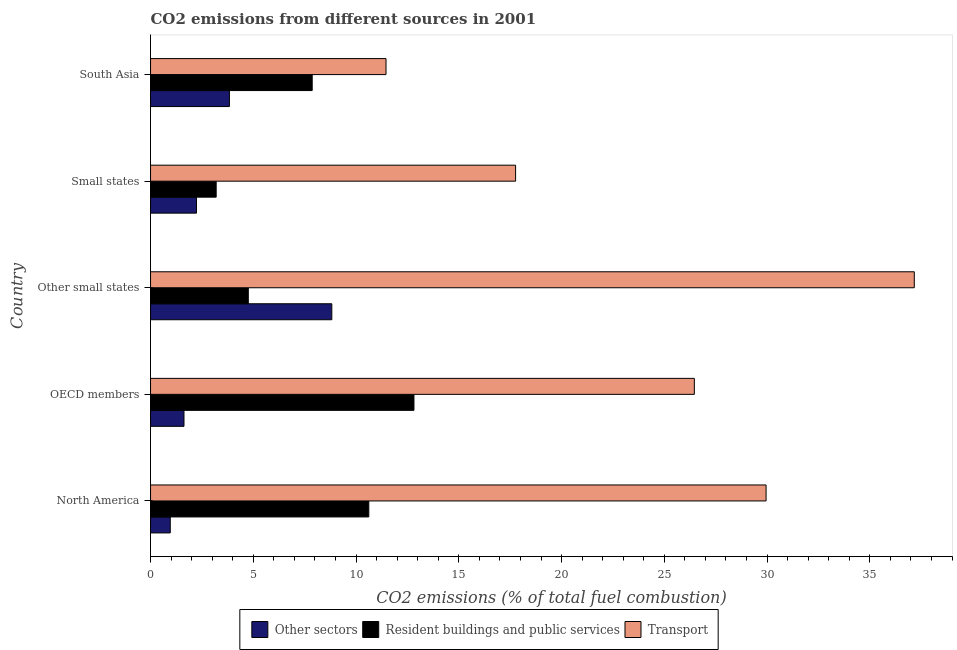Are the number of bars on each tick of the Y-axis equal?
Make the answer very short. Yes. What is the percentage of co2 emissions from resident buildings and public services in South Asia?
Your answer should be compact. 7.87. Across all countries, what is the maximum percentage of co2 emissions from other sectors?
Provide a short and direct response. 8.82. Across all countries, what is the minimum percentage of co2 emissions from other sectors?
Your answer should be compact. 0.96. In which country was the percentage of co2 emissions from resident buildings and public services maximum?
Give a very brief answer. OECD members. In which country was the percentage of co2 emissions from other sectors minimum?
Keep it short and to the point. North America. What is the total percentage of co2 emissions from transport in the graph?
Ensure brevity in your answer.  122.8. What is the difference between the percentage of co2 emissions from other sectors in Other small states and that in South Asia?
Keep it short and to the point. 4.98. What is the difference between the percentage of co2 emissions from other sectors in OECD members and the percentage of co2 emissions from resident buildings and public services in Other small states?
Offer a terse response. -3.13. What is the average percentage of co2 emissions from other sectors per country?
Your response must be concise. 3.5. What is the difference between the percentage of co2 emissions from resident buildings and public services and percentage of co2 emissions from transport in South Asia?
Provide a succinct answer. -3.59. What is the ratio of the percentage of co2 emissions from resident buildings and public services in OECD members to that in South Asia?
Offer a very short reply. 1.63. Is the percentage of co2 emissions from transport in OECD members less than that in South Asia?
Give a very brief answer. No. Is the difference between the percentage of co2 emissions from other sectors in Other small states and Small states greater than the difference between the percentage of co2 emissions from resident buildings and public services in Other small states and Small states?
Offer a terse response. Yes. What is the difference between the highest and the second highest percentage of co2 emissions from resident buildings and public services?
Make the answer very short. 2.2. What is the difference between the highest and the lowest percentage of co2 emissions from transport?
Offer a terse response. 25.71. What does the 2nd bar from the top in Other small states represents?
Provide a short and direct response. Resident buildings and public services. What does the 2nd bar from the bottom in Other small states represents?
Your response must be concise. Resident buildings and public services. How many bars are there?
Provide a short and direct response. 15. What is the difference between two consecutive major ticks on the X-axis?
Provide a succinct answer. 5. Are the values on the major ticks of X-axis written in scientific E-notation?
Make the answer very short. No. Where does the legend appear in the graph?
Your answer should be very brief. Bottom center. How many legend labels are there?
Give a very brief answer. 3. What is the title of the graph?
Provide a short and direct response. CO2 emissions from different sources in 2001. Does "Nuclear sources" appear as one of the legend labels in the graph?
Offer a very short reply. No. What is the label or title of the X-axis?
Your answer should be compact. CO2 emissions (% of total fuel combustion). What is the CO2 emissions (% of total fuel combustion) in Other sectors in North America?
Provide a succinct answer. 0.96. What is the CO2 emissions (% of total fuel combustion) of Resident buildings and public services in North America?
Your answer should be compact. 10.62. What is the CO2 emissions (% of total fuel combustion) of Transport in North America?
Ensure brevity in your answer.  29.95. What is the CO2 emissions (% of total fuel combustion) of Other sectors in OECD members?
Give a very brief answer. 1.63. What is the CO2 emissions (% of total fuel combustion) in Resident buildings and public services in OECD members?
Provide a short and direct response. 12.82. What is the CO2 emissions (% of total fuel combustion) of Transport in OECD members?
Your answer should be compact. 26.46. What is the CO2 emissions (% of total fuel combustion) of Other sectors in Other small states?
Your answer should be very brief. 8.82. What is the CO2 emissions (% of total fuel combustion) in Resident buildings and public services in Other small states?
Your answer should be very brief. 4.76. What is the CO2 emissions (% of total fuel combustion) in Transport in Other small states?
Offer a very short reply. 37.17. What is the CO2 emissions (% of total fuel combustion) in Other sectors in Small states?
Offer a very short reply. 2.24. What is the CO2 emissions (% of total fuel combustion) in Resident buildings and public services in Small states?
Your answer should be compact. 3.19. What is the CO2 emissions (% of total fuel combustion) of Transport in Small states?
Provide a succinct answer. 17.76. What is the CO2 emissions (% of total fuel combustion) in Other sectors in South Asia?
Ensure brevity in your answer.  3.84. What is the CO2 emissions (% of total fuel combustion) in Resident buildings and public services in South Asia?
Ensure brevity in your answer.  7.87. What is the CO2 emissions (% of total fuel combustion) in Transport in South Asia?
Your response must be concise. 11.46. Across all countries, what is the maximum CO2 emissions (% of total fuel combustion) in Other sectors?
Provide a short and direct response. 8.82. Across all countries, what is the maximum CO2 emissions (% of total fuel combustion) in Resident buildings and public services?
Provide a short and direct response. 12.82. Across all countries, what is the maximum CO2 emissions (% of total fuel combustion) in Transport?
Make the answer very short. 37.17. Across all countries, what is the minimum CO2 emissions (% of total fuel combustion) of Other sectors?
Offer a terse response. 0.96. Across all countries, what is the minimum CO2 emissions (% of total fuel combustion) of Resident buildings and public services?
Make the answer very short. 3.19. Across all countries, what is the minimum CO2 emissions (% of total fuel combustion) in Transport?
Provide a short and direct response. 11.46. What is the total CO2 emissions (% of total fuel combustion) in Other sectors in the graph?
Your response must be concise. 17.48. What is the total CO2 emissions (% of total fuel combustion) in Resident buildings and public services in the graph?
Provide a succinct answer. 39.26. What is the total CO2 emissions (% of total fuel combustion) of Transport in the graph?
Make the answer very short. 122.8. What is the difference between the CO2 emissions (% of total fuel combustion) of Other sectors in North America and that in OECD members?
Make the answer very short. -0.67. What is the difference between the CO2 emissions (% of total fuel combustion) in Resident buildings and public services in North America and that in OECD members?
Offer a terse response. -2.2. What is the difference between the CO2 emissions (% of total fuel combustion) of Transport in North America and that in OECD members?
Your answer should be compact. 3.49. What is the difference between the CO2 emissions (% of total fuel combustion) in Other sectors in North America and that in Other small states?
Offer a terse response. -7.86. What is the difference between the CO2 emissions (% of total fuel combustion) of Resident buildings and public services in North America and that in Other small states?
Provide a succinct answer. 5.86. What is the difference between the CO2 emissions (% of total fuel combustion) in Transport in North America and that in Other small states?
Provide a succinct answer. -7.21. What is the difference between the CO2 emissions (% of total fuel combustion) in Other sectors in North America and that in Small states?
Keep it short and to the point. -1.28. What is the difference between the CO2 emissions (% of total fuel combustion) of Resident buildings and public services in North America and that in Small states?
Make the answer very short. 7.43. What is the difference between the CO2 emissions (% of total fuel combustion) in Transport in North America and that in Small states?
Your answer should be very brief. 12.19. What is the difference between the CO2 emissions (% of total fuel combustion) in Other sectors in North America and that in South Asia?
Your response must be concise. -2.88. What is the difference between the CO2 emissions (% of total fuel combustion) in Resident buildings and public services in North America and that in South Asia?
Your response must be concise. 2.75. What is the difference between the CO2 emissions (% of total fuel combustion) of Transport in North America and that in South Asia?
Make the answer very short. 18.49. What is the difference between the CO2 emissions (% of total fuel combustion) in Other sectors in OECD members and that in Other small states?
Give a very brief answer. -7.19. What is the difference between the CO2 emissions (% of total fuel combustion) of Resident buildings and public services in OECD members and that in Other small states?
Keep it short and to the point. 8.06. What is the difference between the CO2 emissions (% of total fuel combustion) of Transport in OECD members and that in Other small states?
Your response must be concise. -10.7. What is the difference between the CO2 emissions (% of total fuel combustion) of Other sectors in OECD members and that in Small states?
Your answer should be compact. -0.61. What is the difference between the CO2 emissions (% of total fuel combustion) of Resident buildings and public services in OECD members and that in Small states?
Provide a succinct answer. 9.62. What is the difference between the CO2 emissions (% of total fuel combustion) of Transport in OECD members and that in Small states?
Give a very brief answer. 8.7. What is the difference between the CO2 emissions (% of total fuel combustion) of Other sectors in OECD members and that in South Asia?
Provide a succinct answer. -2.21. What is the difference between the CO2 emissions (% of total fuel combustion) in Resident buildings and public services in OECD members and that in South Asia?
Offer a terse response. 4.95. What is the difference between the CO2 emissions (% of total fuel combustion) in Transport in OECD members and that in South Asia?
Your response must be concise. 15. What is the difference between the CO2 emissions (% of total fuel combustion) in Other sectors in Other small states and that in Small states?
Give a very brief answer. 6.58. What is the difference between the CO2 emissions (% of total fuel combustion) in Resident buildings and public services in Other small states and that in Small states?
Keep it short and to the point. 1.56. What is the difference between the CO2 emissions (% of total fuel combustion) in Transport in Other small states and that in Small states?
Your response must be concise. 19.4. What is the difference between the CO2 emissions (% of total fuel combustion) of Other sectors in Other small states and that in South Asia?
Your response must be concise. 4.98. What is the difference between the CO2 emissions (% of total fuel combustion) of Resident buildings and public services in Other small states and that in South Asia?
Keep it short and to the point. -3.11. What is the difference between the CO2 emissions (% of total fuel combustion) in Transport in Other small states and that in South Asia?
Offer a terse response. 25.71. What is the difference between the CO2 emissions (% of total fuel combustion) of Other sectors in Small states and that in South Asia?
Provide a short and direct response. -1.6. What is the difference between the CO2 emissions (% of total fuel combustion) in Resident buildings and public services in Small states and that in South Asia?
Make the answer very short. -4.67. What is the difference between the CO2 emissions (% of total fuel combustion) of Transport in Small states and that in South Asia?
Your answer should be very brief. 6.31. What is the difference between the CO2 emissions (% of total fuel combustion) in Other sectors in North America and the CO2 emissions (% of total fuel combustion) in Resident buildings and public services in OECD members?
Your response must be concise. -11.86. What is the difference between the CO2 emissions (% of total fuel combustion) in Other sectors in North America and the CO2 emissions (% of total fuel combustion) in Transport in OECD members?
Your answer should be very brief. -25.5. What is the difference between the CO2 emissions (% of total fuel combustion) of Resident buildings and public services in North America and the CO2 emissions (% of total fuel combustion) of Transport in OECD members?
Offer a very short reply. -15.84. What is the difference between the CO2 emissions (% of total fuel combustion) in Other sectors in North America and the CO2 emissions (% of total fuel combustion) in Resident buildings and public services in Other small states?
Provide a succinct answer. -3.8. What is the difference between the CO2 emissions (% of total fuel combustion) in Other sectors in North America and the CO2 emissions (% of total fuel combustion) in Transport in Other small states?
Offer a terse response. -36.21. What is the difference between the CO2 emissions (% of total fuel combustion) of Resident buildings and public services in North America and the CO2 emissions (% of total fuel combustion) of Transport in Other small states?
Ensure brevity in your answer.  -26.55. What is the difference between the CO2 emissions (% of total fuel combustion) of Other sectors in North America and the CO2 emissions (% of total fuel combustion) of Resident buildings and public services in Small states?
Offer a very short reply. -2.23. What is the difference between the CO2 emissions (% of total fuel combustion) in Other sectors in North America and the CO2 emissions (% of total fuel combustion) in Transport in Small states?
Provide a short and direct response. -16.8. What is the difference between the CO2 emissions (% of total fuel combustion) of Resident buildings and public services in North America and the CO2 emissions (% of total fuel combustion) of Transport in Small states?
Offer a terse response. -7.14. What is the difference between the CO2 emissions (% of total fuel combustion) of Other sectors in North America and the CO2 emissions (% of total fuel combustion) of Resident buildings and public services in South Asia?
Your answer should be compact. -6.91. What is the difference between the CO2 emissions (% of total fuel combustion) of Other sectors in North America and the CO2 emissions (% of total fuel combustion) of Transport in South Asia?
Make the answer very short. -10.5. What is the difference between the CO2 emissions (% of total fuel combustion) of Resident buildings and public services in North America and the CO2 emissions (% of total fuel combustion) of Transport in South Asia?
Your answer should be very brief. -0.84. What is the difference between the CO2 emissions (% of total fuel combustion) in Other sectors in OECD members and the CO2 emissions (% of total fuel combustion) in Resident buildings and public services in Other small states?
Give a very brief answer. -3.13. What is the difference between the CO2 emissions (% of total fuel combustion) of Other sectors in OECD members and the CO2 emissions (% of total fuel combustion) of Transport in Other small states?
Provide a short and direct response. -35.54. What is the difference between the CO2 emissions (% of total fuel combustion) in Resident buildings and public services in OECD members and the CO2 emissions (% of total fuel combustion) in Transport in Other small states?
Your answer should be very brief. -24.35. What is the difference between the CO2 emissions (% of total fuel combustion) of Other sectors in OECD members and the CO2 emissions (% of total fuel combustion) of Resident buildings and public services in Small states?
Your answer should be very brief. -1.57. What is the difference between the CO2 emissions (% of total fuel combustion) of Other sectors in OECD members and the CO2 emissions (% of total fuel combustion) of Transport in Small states?
Your response must be concise. -16.14. What is the difference between the CO2 emissions (% of total fuel combustion) in Resident buildings and public services in OECD members and the CO2 emissions (% of total fuel combustion) in Transport in Small states?
Offer a terse response. -4.95. What is the difference between the CO2 emissions (% of total fuel combustion) in Other sectors in OECD members and the CO2 emissions (% of total fuel combustion) in Resident buildings and public services in South Asia?
Your answer should be very brief. -6.24. What is the difference between the CO2 emissions (% of total fuel combustion) in Other sectors in OECD members and the CO2 emissions (% of total fuel combustion) in Transport in South Asia?
Your answer should be compact. -9.83. What is the difference between the CO2 emissions (% of total fuel combustion) of Resident buildings and public services in OECD members and the CO2 emissions (% of total fuel combustion) of Transport in South Asia?
Offer a terse response. 1.36. What is the difference between the CO2 emissions (% of total fuel combustion) in Other sectors in Other small states and the CO2 emissions (% of total fuel combustion) in Resident buildings and public services in Small states?
Provide a short and direct response. 5.63. What is the difference between the CO2 emissions (% of total fuel combustion) in Other sectors in Other small states and the CO2 emissions (% of total fuel combustion) in Transport in Small states?
Offer a terse response. -8.94. What is the difference between the CO2 emissions (% of total fuel combustion) of Resident buildings and public services in Other small states and the CO2 emissions (% of total fuel combustion) of Transport in Small states?
Provide a short and direct response. -13.01. What is the difference between the CO2 emissions (% of total fuel combustion) in Other sectors in Other small states and the CO2 emissions (% of total fuel combustion) in Resident buildings and public services in South Asia?
Provide a succinct answer. 0.95. What is the difference between the CO2 emissions (% of total fuel combustion) of Other sectors in Other small states and the CO2 emissions (% of total fuel combustion) of Transport in South Asia?
Your answer should be compact. -2.64. What is the difference between the CO2 emissions (% of total fuel combustion) of Resident buildings and public services in Other small states and the CO2 emissions (% of total fuel combustion) of Transport in South Asia?
Offer a terse response. -6.7. What is the difference between the CO2 emissions (% of total fuel combustion) in Other sectors in Small states and the CO2 emissions (% of total fuel combustion) in Resident buildings and public services in South Asia?
Make the answer very short. -5.63. What is the difference between the CO2 emissions (% of total fuel combustion) in Other sectors in Small states and the CO2 emissions (% of total fuel combustion) in Transport in South Asia?
Offer a very short reply. -9.22. What is the difference between the CO2 emissions (% of total fuel combustion) in Resident buildings and public services in Small states and the CO2 emissions (% of total fuel combustion) in Transport in South Asia?
Provide a succinct answer. -8.26. What is the average CO2 emissions (% of total fuel combustion) of Other sectors per country?
Your response must be concise. 3.5. What is the average CO2 emissions (% of total fuel combustion) of Resident buildings and public services per country?
Your response must be concise. 7.85. What is the average CO2 emissions (% of total fuel combustion) of Transport per country?
Offer a terse response. 24.56. What is the difference between the CO2 emissions (% of total fuel combustion) of Other sectors and CO2 emissions (% of total fuel combustion) of Resident buildings and public services in North America?
Your answer should be very brief. -9.66. What is the difference between the CO2 emissions (% of total fuel combustion) of Other sectors and CO2 emissions (% of total fuel combustion) of Transport in North America?
Offer a terse response. -28.99. What is the difference between the CO2 emissions (% of total fuel combustion) of Resident buildings and public services and CO2 emissions (% of total fuel combustion) of Transport in North America?
Your answer should be very brief. -19.33. What is the difference between the CO2 emissions (% of total fuel combustion) in Other sectors and CO2 emissions (% of total fuel combustion) in Resident buildings and public services in OECD members?
Keep it short and to the point. -11.19. What is the difference between the CO2 emissions (% of total fuel combustion) of Other sectors and CO2 emissions (% of total fuel combustion) of Transport in OECD members?
Your answer should be compact. -24.83. What is the difference between the CO2 emissions (% of total fuel combustion) in Resident buildings and public services and CO2 emissions (% of total fuel combustion) in Transport in OECD members?
Provide a short and direct response. -13.64. What is the difference between the CO2 emissions (% of total fuel combustion) in Other sectors and CO2 emissions (% of total fuel combustion) in Resident buildings and public services in Other small states?
Your response must be concise. 4.06. What is the difference between the CO2 emissions (% of total fuel combustion) in Other sectors and CO2 emissions (% of total fuel combustion) in Transport in Other small states?
Offer a very short reply. -28.34. What is the difference between the CO2 emissions (% of total fuel combustion) in Resident buildings and public services and CO2 emissions (% of total fuel combustion) in Transport in Other small states?
Provide a short and direct response. -32.41. What is the difference between the CO2 emissions (% of total fuel combustion) of Other sectors and CO2 emissions (% of total fuel combustion) of Resident buildings and public services in Small states?
Provide a short and direct response. -0.96. What is the difference between the CO2 emissions (% of total fuel combustion) in Other sectors and CO2 emissions (% of total fuel combustion) in Transport in Small states?
Your answer should be very brief. -15.53. What is the difference between the CO2 emissions (% of total fuel combustion) of Resident buildings and public services and CO2 emissions (% of total fuel combustion) of Transport in Small states?
Your answer should be very brief. -14.57. What is the difference between the CO2 emissions (% of total fuel combustion) in Other sectors and CO2 emissions (% of total fuel combustion) in Resident buildings and public services in South Asia?
Your answer should be compact. -4.03. What is the difference between the CO2 emissions (% of total fuel combustion) of Other sectors and CO2 emissions (% of total fuel combustion) of Transport in South Asia?
Provide a succinct answer. -7.62. What is the difference between the CO2 emissions (% of total fuel combustion) of Resident buildings and public services and CO2 emissions (% of total fuel combustion) of Transport in South Asia?
Offer a terse response. -3.59. What is the ratio of the CO2 emissions (% of total fuel combustion) in Other sectors in North America to that in OECD members?
Provide a short and direct response. 0.59. What is the ratio of the CO2 emissions (% of total fuel combustion) of Resident buildings and public services in North America to that in OECD members?
Your answer should be compact. 0.83. What is the ratio of the CO2 emissions (% of total fuel combustion) in Transport in North America to that in OECD members?
Provide a succinct answer. 1.13. What is the ratio of the CO2 emissions (% of total fuel combustion) of Other sectors in North America to that in Other small states?
Provide a short and direct response. 0.11. What is the ratio of the CO2 emissions (% of total fuel combustion) in Resident buildings and public services in North America to that in Other small states?
Ensure brevity in your answer.  2.23. What is the ratio of the CO2 emissions (% of total fuel combustion) in Transport in North America to that in Other small states?
Offer a terse response. 0.81. What is the ratio of the CO2 emissions (% of total fuel combustion) of Other sectors in North America to that in Small states?
Ensure brevity in your answer.  0.43. What is the ratio of the CO2 emissions (% of total fuel combustion) in Resident buildings and public services in North America to that in Small states?
Provide a succinct answer. 3.33. What is the ratio of the CO2 emissions (% of total fuel combustion) in Transport in North America to that in Small states?
Your answer should be very brief. 1.69. What is the ratio of the CO2 emissions (% of total fuel combustion) of Other sectors in North America to that in South Asia?
Provide a short and direct response. 0.25. What is the ratio of the CO2 emissions (% of total fuel combustion) in Resident buildings and public services in North America to that in South Asia?
Your answer should be very brief. 1.35. What is the ratio of the CO2 emissions (% of total fuel combustion) of Transport in North America to that in South Asia?
Ensure brevity in your answer.  2.61. What is the ratio of the CO2 emissions (% of total fuel combustion) in Other sectors in OECD members to that in Other small states?
Provide a short and direct response. 0.18. What is the ratio of the CO2 emissions (% of total fuel combustion) of Resident buildings and public services in OECD members to that in Other small states?
Offer a terse response. 2.69. What is the ratio of the CO2 emissions (% of total fuel combustion) of Transport in OECD members to that in Other small states?
Keep it short and to the point. 0.71. What is the ratio of the CO2 emissions (% of total fuel combustion) of Other sectors in OECD members to that in Small states?
Give a very brief answer. 0.73. What is the ratio of the CO2 emissions (% of total fuel combustion) in Resident buildings and public services in OECD members to that in Small states?
Ensure brevity in your answer.  4.01. What is the ratio of the CO2 emissions (% of total fuel combustion) of Transport in OECD members to that in Small states?
Ensure brevity in your answer.  1.49. What is the ratio of the CO2 emissions (% of total fuel combustion) of Other sectors in OECD members to that in South Asia?
Offer a terse response. 0.42. What is the ratio of the CO2 emissions (% of total fuel combustion) of Resident buildings and public services in OECD members to that in South Asia?
Provide a succinct answer. 1.63. What is the ratio of the CO2 emissions (% of total fuel combustion) of Transport in OECD members to that in South Asia?
Make the answer very short. 2.31. What is the ratio of the CO2 emissions (% of total fuel combustion) in Other sectors in Other small states to that in Small states?
Provide a succinct answer. 3.94. What is the ratio of the CO2 emissions (% of total fuel combustion) in Resident buildings and public services in Other small states to that in Small states?
Give a very brief answer. 1.49. What is the ratio of the CO2 emissions (% of total fuel combustion) of Transport in Other small states to that in Small states?
Keep it short and to the point. 2.09. What is the ratio of the CO2 emissions (% of total fuel combustion) of Other sectors in Other small states to that in South Asia?
Offer a very short reply. 2.3. What is the ratio of the CO2 emissions (% of total fuel combustion) in Resident buildings and public services in Other small states to that in South Asia?
Provide a short and direct response. 0.6. What is the ratio of the CO2 emissions (% of total fuel combustion) in Transport in Other small states to that in South Asia?
Keep it short and to the point. 3.24. What is the ratio of the CO2 emissions (% of total fuel combustion) of Other sectors in Small states to that in South Asia?
Provide a short and direct response. 0.58. What is the ratio of the CO2 emissions (% of total fuel combustion) of Resident buildings and public services in Small states to that in South Asia?
Provide a succinct answer. 0.41. What is the ratio of the CO2 emissions (% of total fuel combustion) of Transport in Small states to that in South Asia?
Your answer should be compact. 1.55. What is the difference between the highest and the second highest CO2 emissions (% of total fuel combustion) in Other sectors?
Your answer should be very brief. 4.98. What is the difference between the highest and the second highest CO2 emissions (% of total fuel combustion) in Resident buildings and public services?
Your response must be concise. 2.2. What is the difference between the highest and the second highest CO2 emissions (% of total fuel combustion) of Transport?
Provide a short and direct response. 7.21. What is the difference between the highest and the lowest CO2 emissions (% of total fuel combustion) of Other sectors?
Give a very brief answer. 7.86. What is the difference between the highest and the lowest CO2 emissions (% of total fuel combustion) of Resident buildings and public services?
Provide a succinct answer. 9.62. What is the difference between the highest and the lowest CO2 emissions (% of total fuel combustion) in Transport?
Your response must be concise. 25.71. 